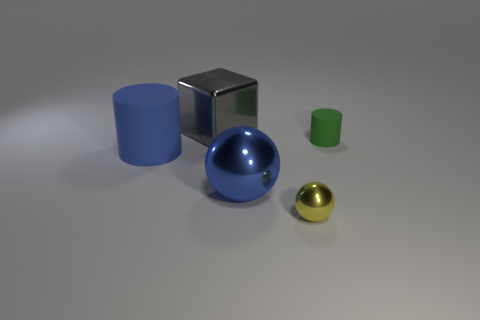What can you tell about the lighting in this scene? The scene is illuminated by a diffused overhead light source, judging by the soft shadows under the objects and the subtle reflections on the glossy surfaces. The lighting appears uniform, suggesting an indoor setting with a controlled lighting environment. 